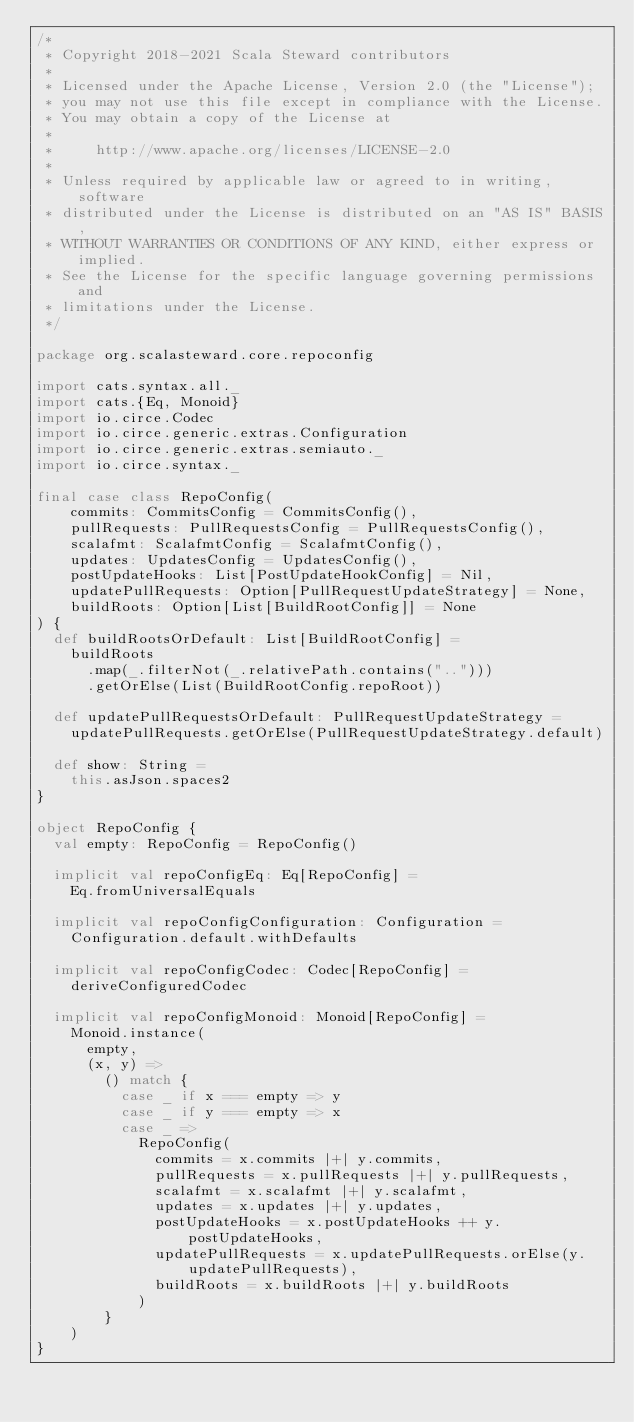Convert code to text. <code><loc_0><loc_0><loc_500><loc_500><_Scala_>/*
 * Copyright 2018-2021 Scala Steward contributors
 *
 * Licensed under the Apache License, Version 2.0 (the "License");
 * you may not use this file except in compliance with the License.
 * You may obtain a copy of the License at
 *
 *     http://www.apache.org/licenses/LICENSE-2.0
 *
 * Unless required by applicable law or agreed to in writing, software
 * distributed under the License is distributed on an "AS IS" BASIS,
 * WITHOUT WARRANTIES OR CONDITIONS OF ANY KIND, either express or implied.
 * See the License for the specific language governing permissions and
 * limitations under the License.
 */

package org.scalasteward.core.repoconfig

import cats.syntax.all._
import cats.{Eq, Monoid}
import io.circe.Codec
import io.circe.generic.extras.Configuration
import io.circe.generic.extras.semiauto._
import io.circe.syntax._

final case class RepoConfig(
    commits: CommitsConfig = CommitsConfig(),
    pullRequests: PullRequestsConfig = PullRequestsConfig(),
    scalafmt: ScalafmtConfig = ScalafmtConfig(),
    updates: UpdatesConfig = UpdatesConfig(),
    postUpdateHooks: List[PostUpdateHookConfig] = Nil,
    updatePullRequests: Option[PullRequestUpdateStrategy] = None,
    buildRoots: Option[List[BuildRootConfig]] = None
) {
  def buildRootsOrDefault: List[BuildRootConfig] =
    buildRoots
      .map(_.filterNot(_.relativePath.contains("..")))
      .getOrElse(List(BuildRootConfig.repoRoot))

  def updatePullRequestsOrDefault: PullRequestUpdateStrategy =
    updatePullRequests.getOrElse(PullRequestUpdateStrategy.default)

  def show: String =
    this.asJson.spaces2
}

object RepoConfig {
  val empty: RepoConfig = RepoConfig()

  implicit val repoConfigEq: Eq[RepoConfig] =
    Eq.fromUniversalEquals

  implicit val repoConfigConfiguration: Configuration =
    Configuration.default.withDefaults

  implicit val repoConfigCodec: Codec[RepoConfig] =
    deriveConfiguredCodec

  implicit val repoConfigMonoid: Monoid[RepoConfig] =
    Monoid.instance(
      empty,
      (x, y) =>
        () match {
          case _ if x === empty => y
          case _ if y === empty => x
          case _ =>
            RepoConfig(
              commits = x.commits |+| y.commits,
              pullRequests = x.pullRequests |+| y.pullRequests,
              scalafmt = x.scalafmt |+| y.scalafmt,
              updates = x.updates |+| y.updates,
              postUpdateHooks = x.postUpdateHooks ++ y.postUpdateHooks,
              updatePullRequests = x.updatePullRequests.orElse(y.updatePullRequests),
              buildRoots = x.buildRoots |+| y.buildRoots
            )
        }
    )
}
</code> 